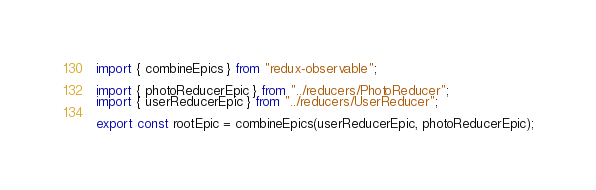<code> <loc_0><loc_0><loc_500><loc_500><_TypeScript_>import { combineEpics } from "redux-observable";

import { photoReducerEpic } from "../reducers/PhotoReducer";
import { userReducerEpic } from "../reducers/UserReducer";

export const rootEpic = combineEpics(userReducerEpic, photoReducerEpic);
</code> 